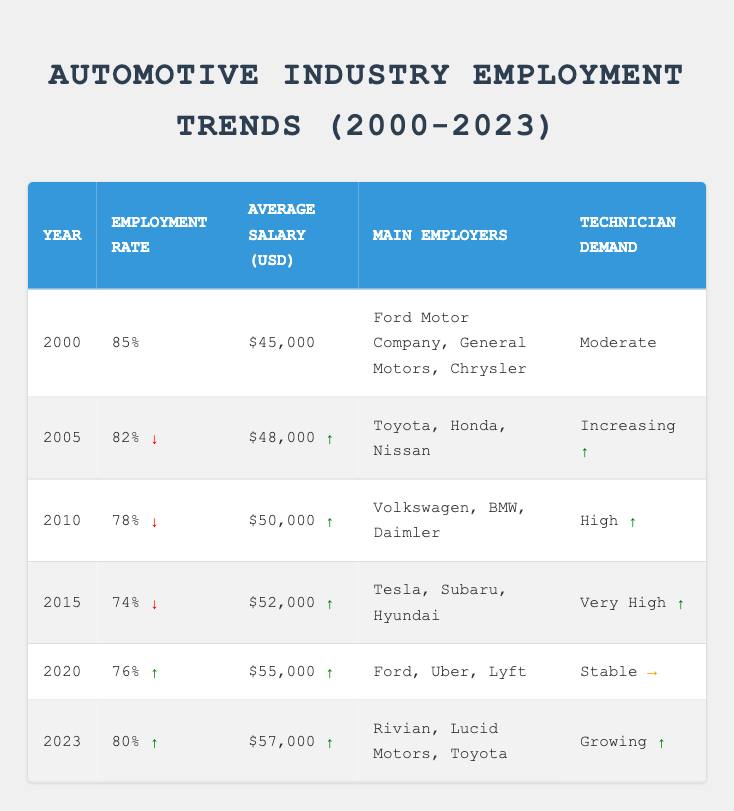What was the average salary for skilled technicians in 2010? The average salary for skilled technicians in 2010, based on the table, is listed as $50,000.
Answer: $50,000 In which year did the employment rate first drop below 80%? According to the table, the employment rate dropped below 80% for the first time in 2010 when it was 78%.
Answer: 2010 What year experienced the highest average salary for technicians? The highest average salary for technicians is found in 2023, where it is $57,000.
Answer: $57,000 Is the technician demand in 2023 higher than it was in 2000? Yes, in 2000 the technician demand was 'Moderate', whereas in 2023 it is 'Growing', indicating an increase in demand.
Answer: Yes Calculate the total employment rate from 2000 to 2023 and find the average. The total employment rate from 2000 to 2023 is the sum of each year's rate: 85 + 82 + 78 + 74 + 76 + 80 = 475. There are 6 years, so the average is 475 / 6 = 79.17%.
Answer: 79.17% Which company was a primary employer in 2010 but not in 2023? In 2010, Volkswagen was a primary employer for skilled technicians, but it is not listed as a main employer in 2023.
Answer: Volkswagen What trend can be observed in the employment rate from 2000 to 2023? The employment rate showed a general decline from 2000 to 2015, dropping to 74%, but then rose to 80% in 2023, indicating an overall recovery.
Answer: Decline then recovery Was there any year where the average salary decreased from the previous year? No, each year from 2000 to 2023 either saw an increase or remained stable in terms of average salary.
Answer: No Which main employer is common between 2020 and 2023? Toyota is the main employer that appears in both 2020 and 2023.
Answer: Toyota How does the employment rate in 2023 compare to that in 2015? The employment rate in 2023 (80%) is higher than in 2015 (74%), indicating an improvement in employment for skilled technicians.
Answer: Higher 